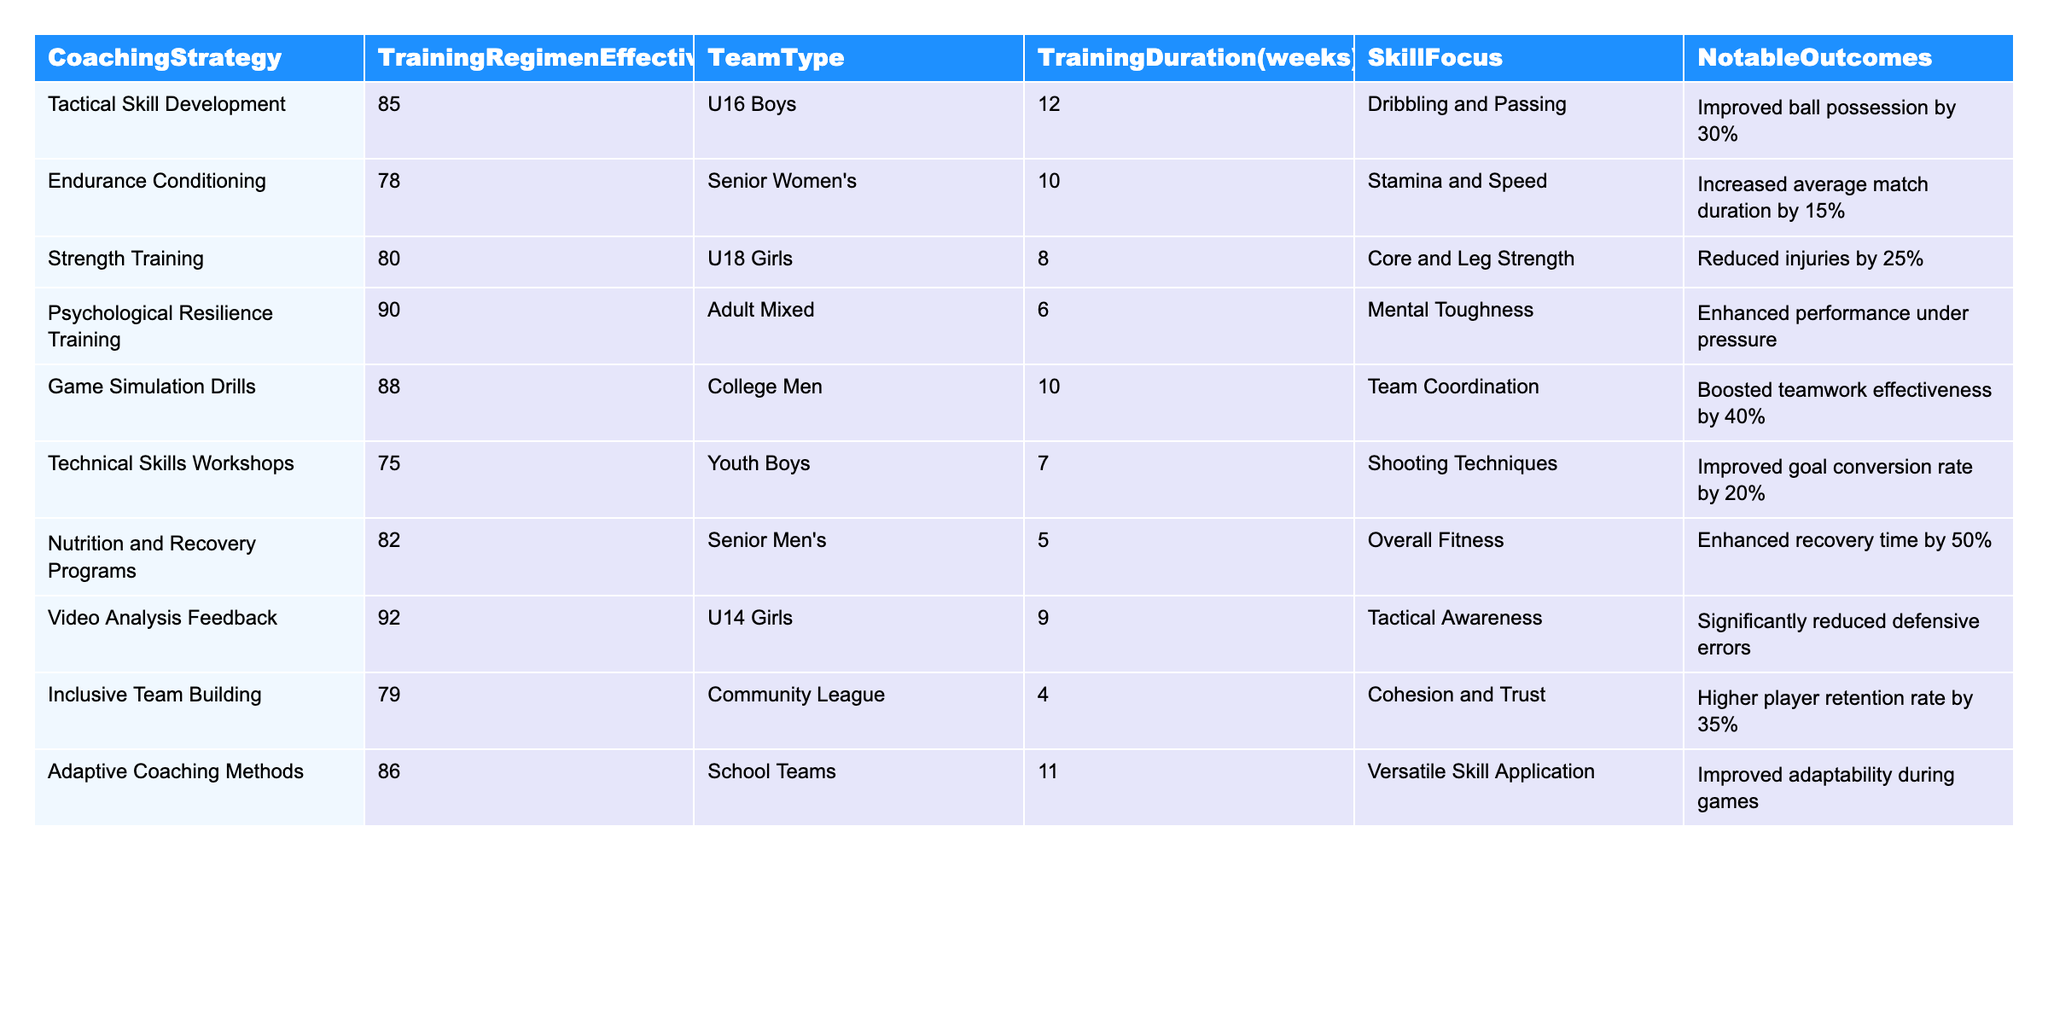What is the highest Training Regimen Effectiveness Score among the coaching strategies? The table shows that "Psychological Resilience Training" has the highest score of 90.
Answer: 90 Which coaching strategy focuses on "Dribbling and Passing"? Referring to the table, "Tactical Skill Development" focuses on "Dribbling and Passing".
Answer: Tactical Skill Development What is the average Training Regimen Effectiveness Score for the strategies focused on physical conditioning? The physical conditioning strategies are "Endurance Conditioning" (78), "Strength Training" (80), and "Nutrition and Recovery Programs" (82). The sum of these scores is 240, and there are 3 strategies, so the average is 240 / 3 = 80.
Answer: 80 Is the "Inclusive Team Building" strategy intended for competitive teams? The table indicates "Inclusive Team Building" is for "Community League", which is not primarily competitive. Therefore, the answer is no.
Answer: No What notable outcome was achieved with the "Video Analysis Feedback" strategy? The notable outcome listed for "Video Analysis Feedback" is a significantly reduced number of defensive errors.
Answer: Significantly reduced defensive errors What is the total Training Duration in weeks for all the strategies that target youth teams? Youth teams include "U16 Boys" (12 weeks), "Youth Boys" (7 weeks), and "U14 Girls" (9 weeks). Totaling these gives 12 + 7 + 9 = 28 weeks.
Answer: 28 weeks Which coaching strategy had the most significant improvement in teamwork effectiveness? The "Game Simulation Drills" strategy had a notable outcome of boosting teamwork effectiveness by 40%.
Answer: Game Simulation Drills How many weeks did the "Strength Training" regimen last? The table states that the "Strength Training" regimen lasted for 8 weeks.
Answer: 8 weeks Which strategy incorporates nutritional aspects, and what is its effectiveness score? The "Nutrition and Recovery Programs" strategy incorporates nutritional aspects, and its effectiveness score is 82.
Answer: 82 What training regimen has the lowest effectiveness score, and what was its focus? "Technical Skills Workshops" has the lowest effectiveness score of 75, focusing on "Shooting Techniques."
Answer: Technical Skills Workshops, 75 